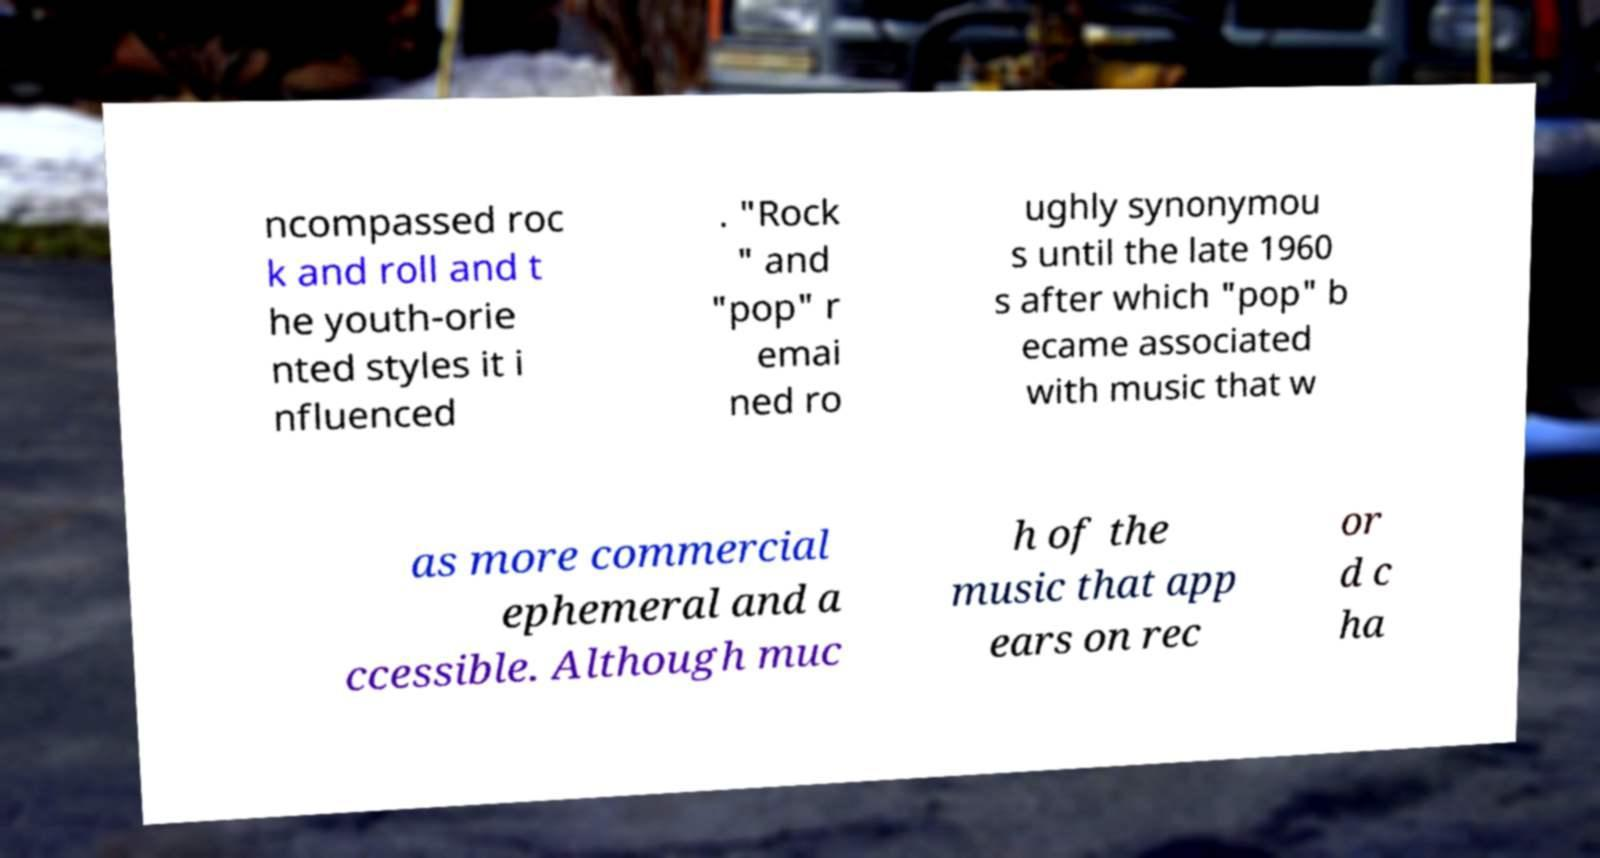What messages or text are displayed in this image? I need them in a readable, typed format. ncompassed roc k and roll and t he youth-orie nted styles it i nfluenced . "Rock " and "pop" r emai ned ro ughly synonymou s until the late 1960 s after which "pop" b ecame associated with music that w as more commercial ephemeral and a ccessible. Although muc h of the music that app ears on rec or d c ha 